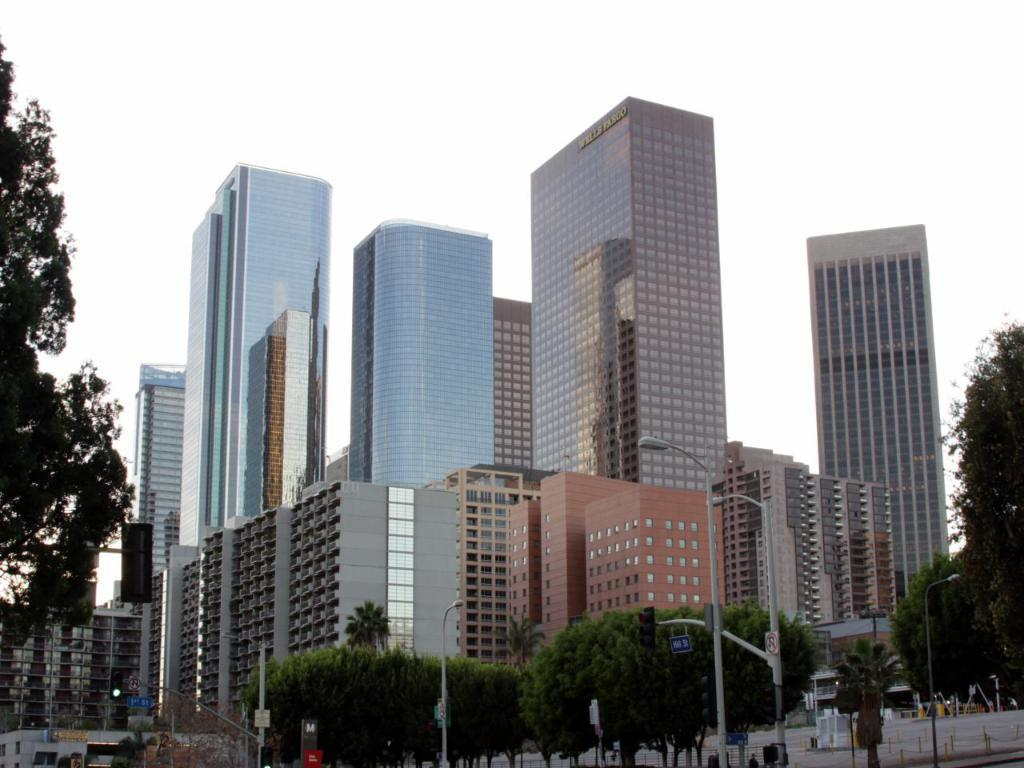What type of structures are present in the image? There are buildings in the image. What other natural elements can be seen in the image? There are trees in the image. What type of lighting is present in the image? There are street lights in the image. What are the poles with boards attached used for in the image? The poles with boards attached are likely used for signage or advertisements. What other objects can be found on the ground in the image? There are other objects on the ground in the image, but their specific nature is not mentioned in the facts. What can be seen in the background of the image? The sky is visible in the background of the image. Can you tell me how many friends are standing next to the appliance in the image? There is no mention of friends or appliances in the image; it features buildings, trees, street lights, poles with boards attached, other objects on the ground, and the sky in the background. 